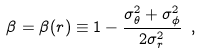Convert formula to latex. <formula><loc_0><loc_0><loc_500><loc_500>\beta = \beta ( r ) \equiv 1 - \frac { \sigma _ { \theta } ^ { 2 } + \sigma _ { \phi } ^ { 2 } } { 2 \sigma _ { r } ^ { 2 } } \ ,</formula> 